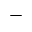<formula> <loc_0><loc_0><loc_500><loc_500>-</formula> 